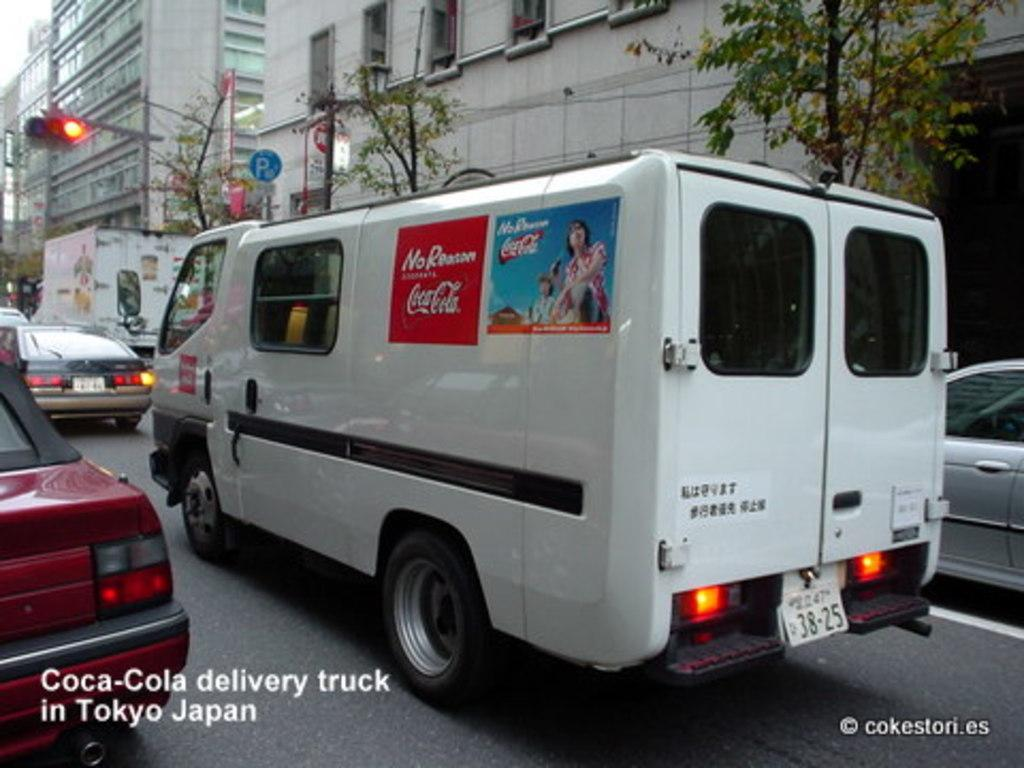<image>
Relay a brief, clear account of the picture shown. A Coca-Cola delivery truck on the street in Tokyo Japan. 